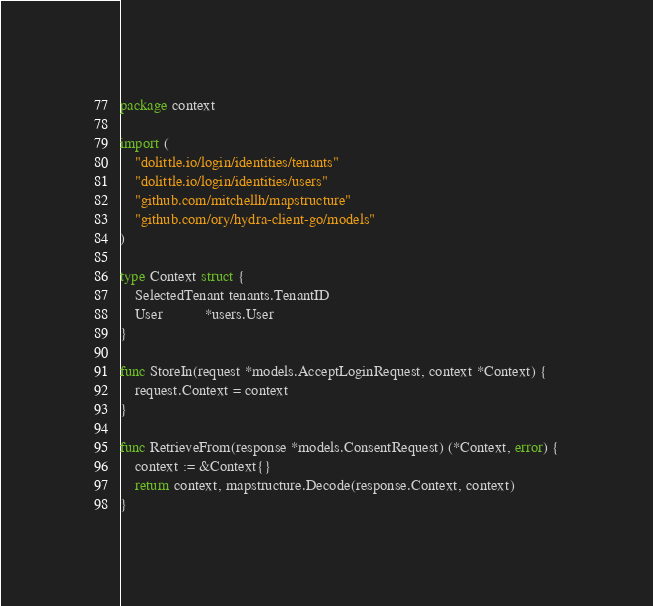Convert code to text. <code><loc_0><loc_0><loc_500><loc_500><_Go_>package context

import (
	"dolittle.io/login/identities/tenants"
	"dolittle.io/login/identities/users"
	"github.com/mitchellh/mapstructure"
	"github.com/ory/hydra-client-go/models"
)

type Context struct {
	SelectedTenant tenants.TenantID
	User           *users.User
}

func StoreIn(request *models.AcceptLoginRequest, context *Context) {
	request.Context = context
}

func RetrieveFrom(response *models.ConsentRequest) (*Context, error) {
	context := &Context{}
	return context, mapstructure.Decode(response.Context, context)
}
</code> 